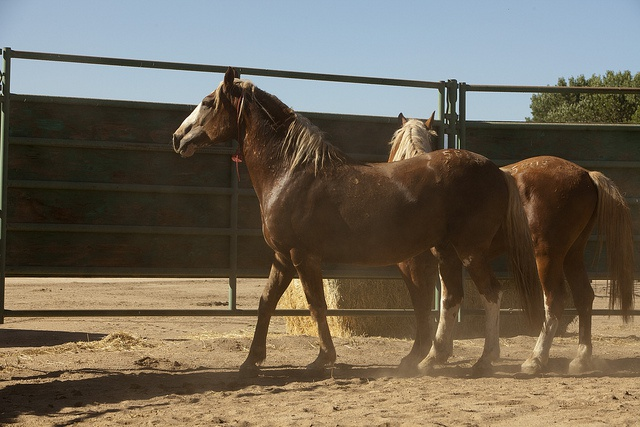Describe the objects in this image and their specific colors. I can see horse in darkgray, black, maroon, and gray tones and horse in darkgray, black, maroon, and gray tones in this image. 